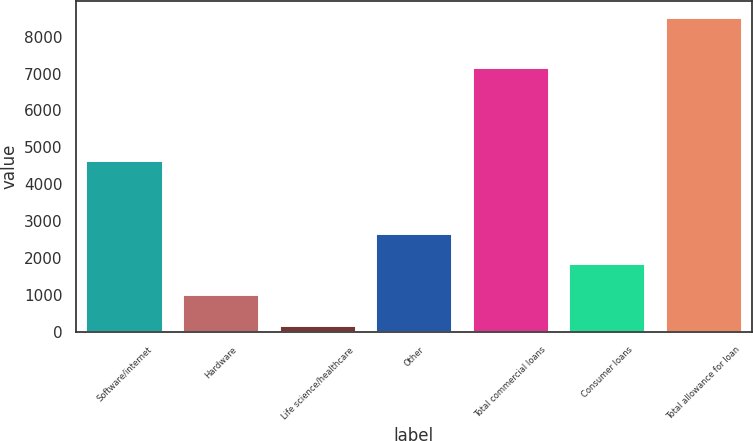Convert chart. <chart><loc_0><loc_0><loc_500><loc_500><bar_chart><fcel>Software/internet<fcel>Hardware<fcel>Life science/healthcare<fcel>Other<fcel>Total commercial loans<fcel>Consumer loans<fcel>Total allowance for loan<nl><fcel>4649<fcel>1023.9<fcel>189<fcel>2693.7<fcel>7175<fcel>1858.8<fcel>8538<nl></chart> 